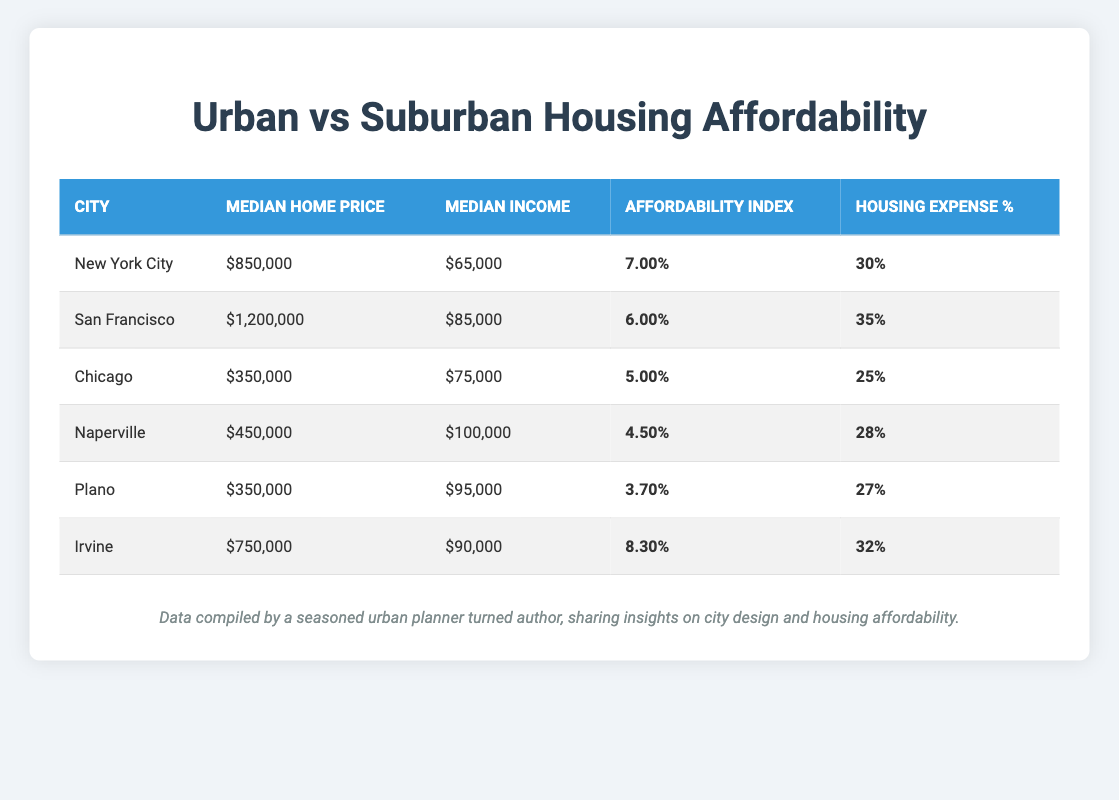What is the median home price in San Francisco? The table lists San Francisco's median home price, which is presented clearly in the "Median Home Price" column. That value is $1,200,000.
Answer: $1,200,000 Which city has the highest affordability index in the suburban category? Looking at the suburban cities listed, the affordability index values are 4.50 for Naperville, 3.70 for Plano, and 8.30 for Irvine. The highest value is 8.30 for Irvine.
Answer: Irvine What is the difference in median income between Naperville and Chicago? The median income in Naperville is $100,000, while in Chicago it is $75,000. To find the difference, we subtract: $100,000 - $75,000 = $25,000.
Answer: $25,000 Is the median home price in Chicago less than the median home price in Plano? The median home price in Chicago is $350,000, while in Plano, it is the same at $350,000. Since these values are equal, the statement is false.
Answer: No What is the average housing expense percentage for urban cities? The housing expense percentages for urban cities are 30 for New York City, 35 for San Francisco, and 25 for Chicago. We sum these values: 30 + 35 + 25 = 90, and then divide by 3 to get the average: 90 / 3 = 30.
Answer: 30 What city has the lowest affordability index overall? By checking the affordability indices for each city, we find New York City (0.07), San Francisco (0.06), Chicago (0.05), Naperville (0.045), Plano (0.037), and Irvine (0.083). The overall lowest is Plano at 0.037.
Answer: Plano What is the total median home price for all suburban cities combined? The median home prices for suburban cities are $450,000 (Naperville), $350,000 (Plano), and $750,000 (Irvine). Adding these gives: $450,000 + $350,000 + $750,000 = $1,550,000.
Answer: $1,550,000 Which urban city has the highest housing expense percentage? Looking at the housing expense percentages: New York City is 30%, San Francisco is 35%, and Chicago is 25%. The highest percentage is 35% in San Francisco.
Answer: San Francisco 